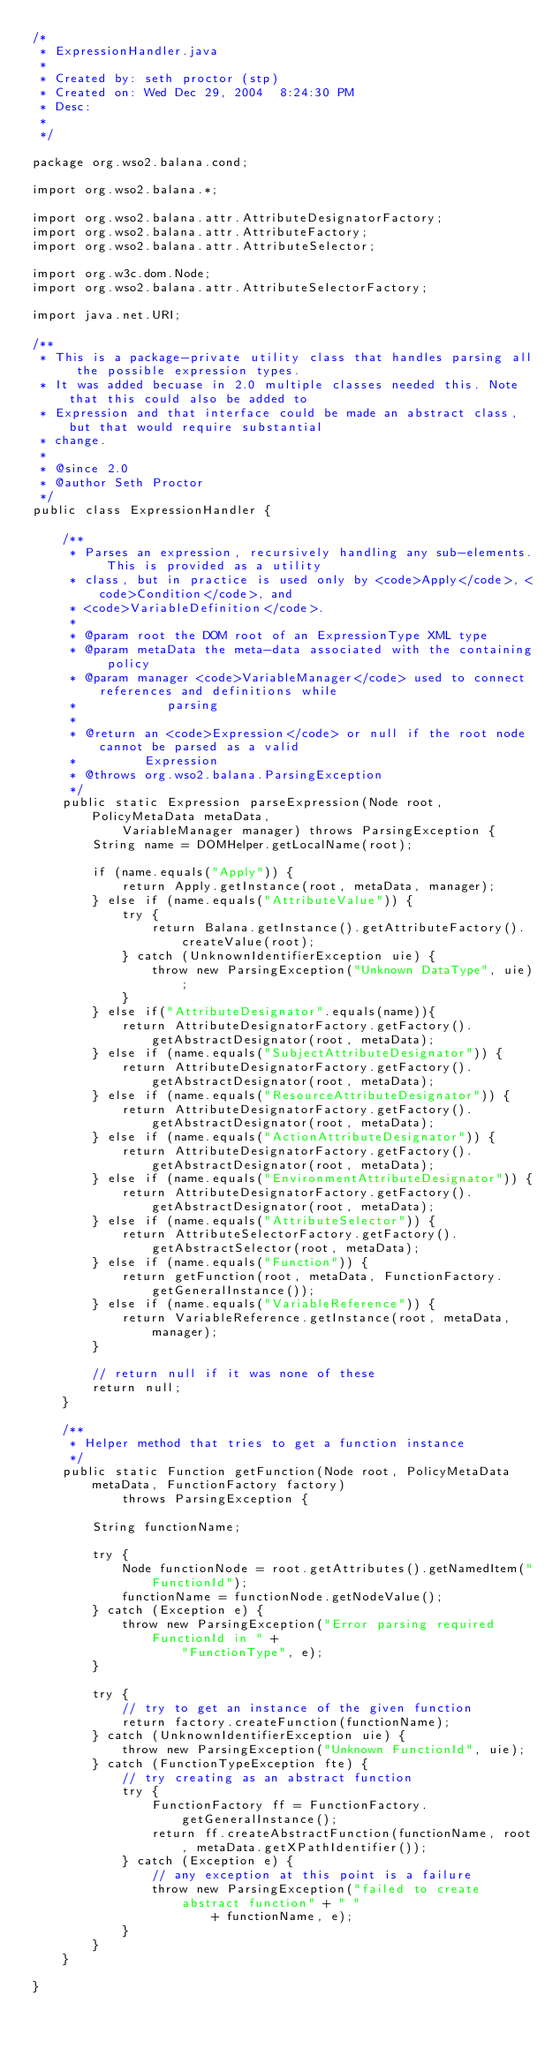<code> <loc_0><loc_0><loc_500><loc_500><_Java_>/*
 * ExpressionHandler.java
 *
 * Created by: seth proctor (stp)
 * Created on: Wed Dec 29, 2004	 8:24:30 PM
 * Desc: 
 *
 */

package org.wso2.balana.cond;

import org.wso2.balana.*;

import org.wso2.balana.attr.AttributeDesignatorFactory;
import org.wso2.balana.attr.AttributeFactory;
import org.wso2.balana.attr.AttributeSelector;

import org.w3c.dom.Node;
import org.wso2.balana.attr.AttributeSelectorFactory;

import java.net.URI;

/**
 * This is a package-private utility class that handles parsing all the possible expression types.
 * It was added becuase in 2.0 multiple classes needed this. Note that this could also be added to
 * Expression and that interface could be made an abstract class, but that would require substantial
 * change.
 * 
 * @since 2.0
 * @author Seth Proctor
 */
public class ExpressionHandler {

    /**
     * Parses an expression, recursively handling any sub-elements. This is provided as a utility
     * class, but in practice is used only by <code>Apply</code>, <code>Condition</code>, and
     * <code>VariableDefinition</code>.
     * 
     * @param root the DOM root of an ExpressionType XML type
     * @param metaData the meta-data associated with the containing policy
     * @param manager <code>VariableManager</code> used to connect references and definitions while
     *            parsing
     * 
     * @return an <code>Expression</code> or null if the root node cannot be parsed as a valid
     *         Expression
     * @throws org.wso2.balana.ParsingException
     */
    public static Expression parseExpression(Node root, PolicyMetaData metaData,
            VariableManager manager) throws ParsingException {
        String name = DOMHelper.getLocalName(root);

        if (name.equals("Apply")) {
            return Apply.getInstance(root, metaData, manager);
        } else if (name.equals("AttributeValue")) {
            try {
                return Balana.getInstance().getAttributeFactory().createValue(root);
            } catch (UnknownIdentifierException uie) {
                throw new ParsingException("Unknown DataType", uie);
            }
        } else if("AttributeDesignator".equals(name)){
            return AttributeDesignatorFactory.getFactory().getAbstractDesignator(root, metaData);
        } else if (name.equals("SubjectAttributeDesignator")) {
            return AttributeDesignatorFactory.getFactory().getAbstractDesignator(root, metaData);
        } else if (name.equals("ResourceAttributeDesignator")) {
            return AttributeDesignatorFactory.getFactory().getAbstractDesignator(root, metaData);
        } else if (name.equals("ActionAttributeDesignator")) {
            return AttributeDesignatorFactory.getFactory().getAbstractDesignator(root, metaData);
        } else if (name.equals("EnvironmentAttributeDesignator")) {
            return AttributeDesignatorFactory.getFactory().getAbstractDesignator(root, metaData);
        } else if (name.equals("AttributeSelector")) {
            return AttributeSelectorFactory.getFactory().getAbstractSelector(root, metaData);
        } else if (name.equals("Function")) {
            return getFunction(root, metaData, FunctionFactory.getGeneralInstance());
        } else if (name.equals("VariableReference")) {
            return VariableReference.getInstance(root, metaData, manager);
        }

        // return null if it was none of these
        return null;
    }

    /**
     * Helper method that tries to get a function instance
     */
    public static Function getFunction(Node root, PolicyMetaData metaData, FunctionFactory factory)
            throws ParsingException {

        String functionName;

        try {
            Node functionNode = root.getAttributes().getNamedItem("FunctionId");
            functionName = functionNode.getNodeValue();
        } catch (Exception e) {
            throw new ParsingException("Error parsing required FunctionId in " +
                    "FunctionType", e);
        }

        try {
            // try to get an instance of the given function
            return factory.createFunction(functionName);
        } catch (UnknownIdentifierException uie) {
            throw new ParsingException("Unknown FunctionId", uie);
        } catch (FunctionTypeException fte) {
            // try creating as an abstract function
            try {
                FunctionFactory ff = FunctionFactory.getGeneralInstance();
                return ff.createAbstractFunction(functionName, root, metaData.getXPathIdentifier());
            } catch (Exception e) {
                // any exception at this point is a failure
                throw new ParsingException("failed to create abstract function" + " "
                        + functionName, e);
            }
        }
    }

}
</code> 